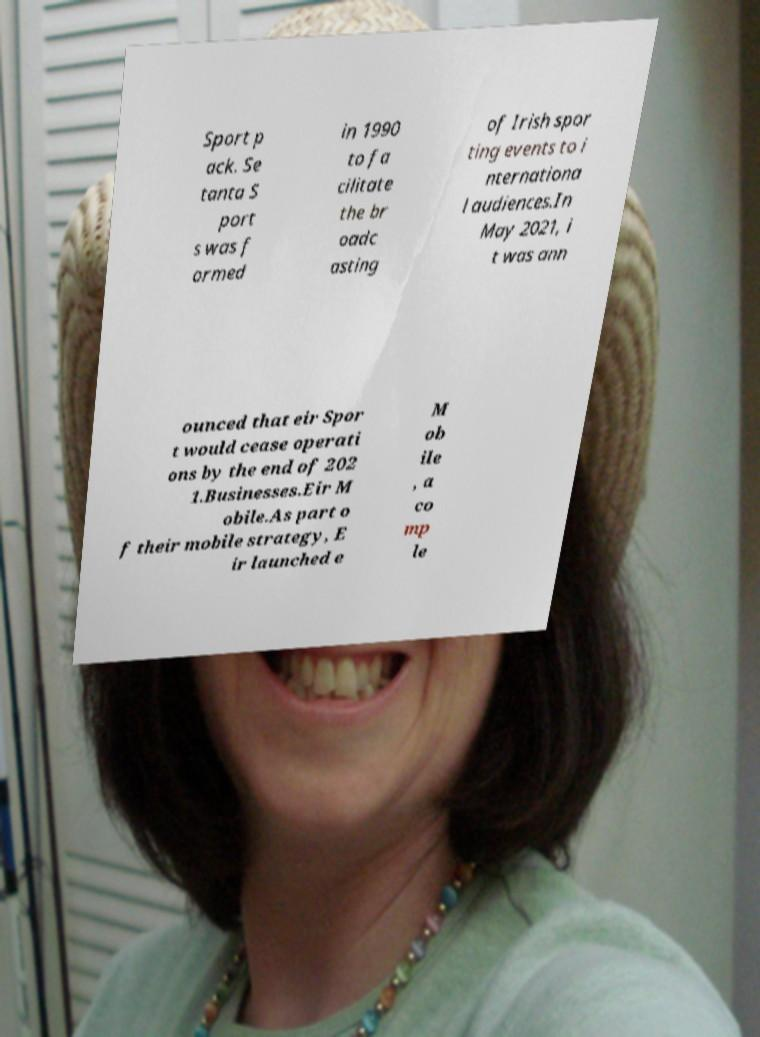Please identify and transcribe the text found in this image. Sport p ack. Se tanta S port s was f ormed in 1990 to fa cilitate the br oadc asting of Irish spor ting events to i nternationa l audiences.In May 2021, i t was ann ounced that eir Spor t would cease operati ons by the end of 202 1.Businesses.Eir M obile.As part o f their mobile strategy, E ir launched e M ob ile , a co mp le 